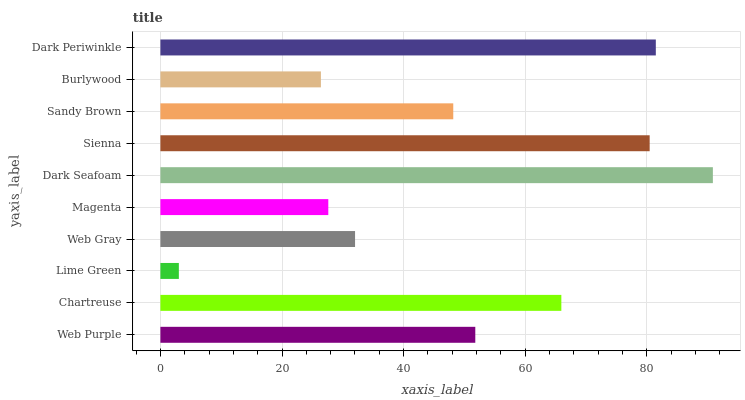Is Lime Green the minimum?
Answer yes or no. Yes. Is Dark Seafoam the maximum?
Answer yes or no. Yes. Is Chartreuse the minimum?
Answer yes or no. No. Is Chartreuse the maximum?
Answer yes or no. No. Is Chartreuse greater than Web Purple?
Answer yes or no. Yes. Is Web Purple less than Chartreuse?
Answer yes or no. Yes. Is Web Purple greater than Chartreuse?
Answer yes or no. No. Is Chartreuse less than Web Purple?
Answer yes or no. No. Is Web Purple the high median?
Answer yes or no. Yes. Is Sandy Brown the low median?
Answer yes or no. Yes. Is Web Gray the high median?
Answer yes or no. No. Is Sienna the low median?
Answer yes or no. No. 